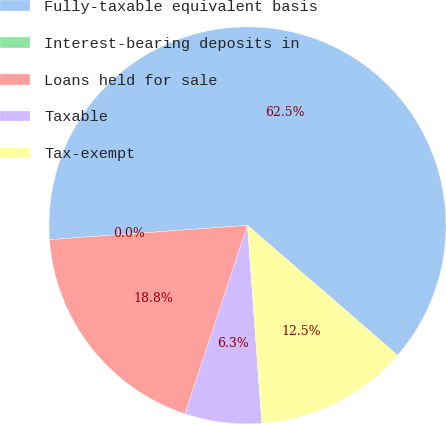<chart> <loc_0><loc_0><loc_500><loc_500><pie_chart><fcel>Fully-taxable equivalent basis<fcel>Interest-bearing deposits in<fcel>Loans held for sale<fcel>Taxable<fcel>Tax-exempt<nl><fcel>62.49%<fcel>0.0%<fcel>18.75%<fcel>6.25%<fcel>12.5%<nl></chart> 